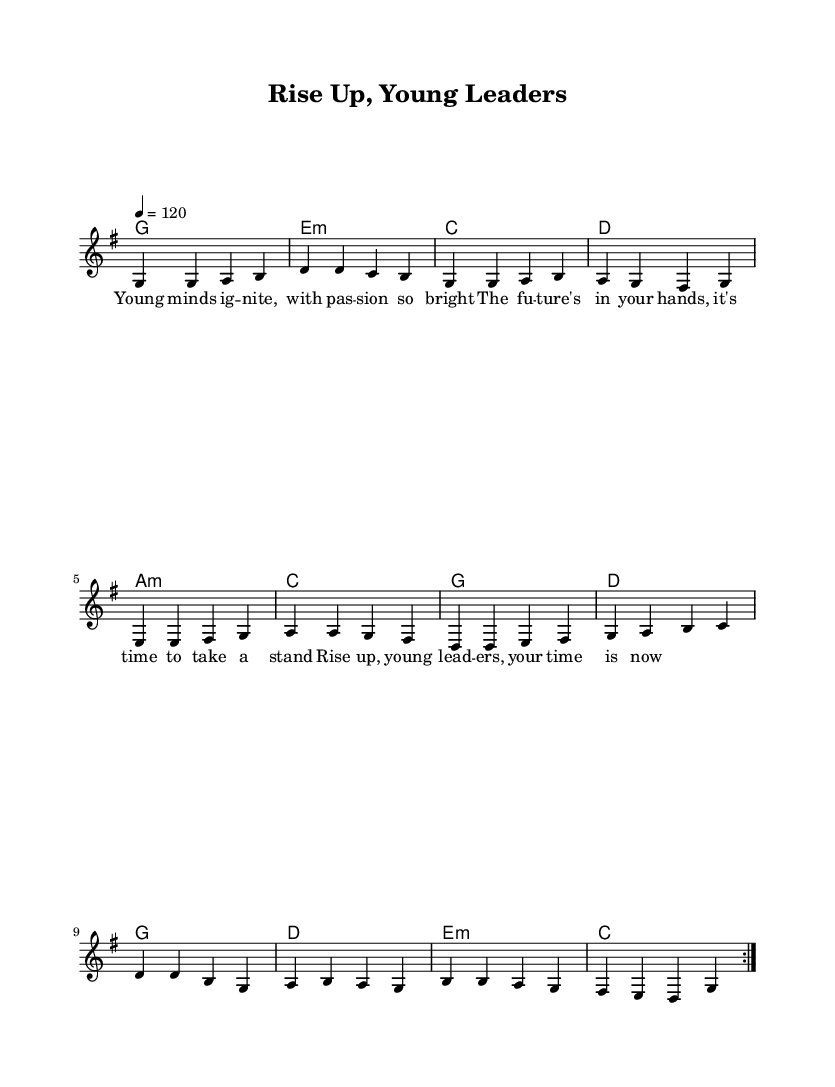What is the key signature of this music? The key signature indicates that there is one sharp, which means the piece is in G major.
Answer: G major What is the time signature of this music? The time signature is indicated at the beginning of the piece and shows that there are four beats in each measure.
Answer: 4/4 What is the tempo marking for this music? The tempo marking instructs that the piece should be played at 120 beats per minute, as indicated by the "4 = 120" notation.
Answer: 120 How many times is the main melody repeated? The repeat signs in the melody indicate that the entire section should be repeated two times.
Answer: 2 What do the lyrics primarily focus on? The lyrics focus on themes of empowerment and encouraging young leaders to take action for the future.
Answer: Empowerment What is the emotional tone conveyed by the song's title and lyrics? The title "Rise Up, Young Leaders" combined with the lyrics suggests an uplifting and motivational tone directed at inspiring youth.
Answer: Uplifting What type of chord progression is used in the harmonies section? The chord progression follows a common structure typically found in rock music, utilizing major and minor chords, creating a feeling of resolution and energy.
Answer: Major and minor chords 